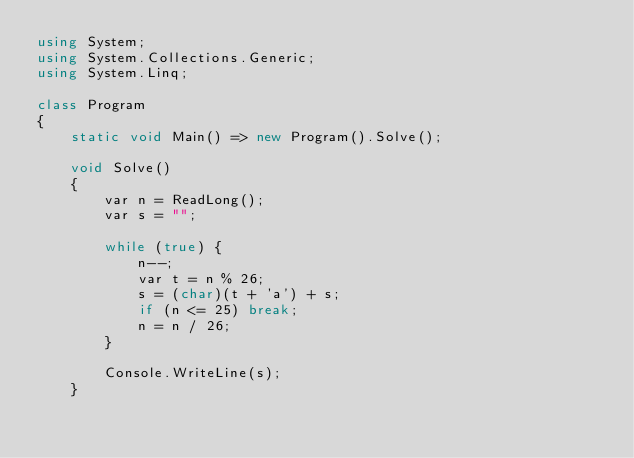<code> <loc_0><loc_0><loc_500><loc_500><_C#_>using System;
using System.Collections.Generic;
using System.Linq;

class Program
{
	static void Main() => new Program().Solve();

	void Solve()
	{
		var n = ReadLong();
		var s = "";

		while (true) {
			n--;
			var t = n % 26;
			s = (char)(t + 'a') + s;
			if (n <= 25) break;
			n = n / 26;
		}

		Console.WriteLine(s);
	}
</code> 